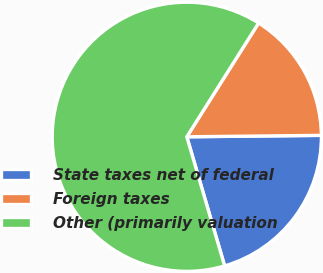<chart> <loc_0><loc_0><loc_500><loc_500><pie_chart><fcel>State taxes net of federal<fcel>Foreign taxes<fcel>Other (primarily valuation<nl><fcel>20.63%<fcel>15.87%<fcel>63.49%<nl></chart> 